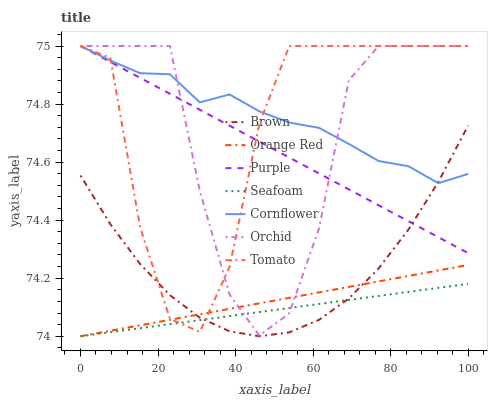Does Seafoam have the minimum area under the curve?
Answer yes or no. Yes. Does Cornflower have the maximum area under the curve?
Answer yes or no. Yes. Does Brown have the minimum area under the curve?
Answer yes or no. No. Does Brown have the maximum area under the curve?
Answer yes or no. No. Is Orange Red the smoothest?
Answer yes or no. Yes. Is Tomato the roughest?
Answer yes or no. Yes. Is Brown the smoothest?
Answer yes or no. No. Is Brown the roughest?
Answer yes or no. No. Does Seafoam have the lowest value?
Answer yes or no. Yes. Does Brown have the lowest value?
Answer yes or no. No. Does Orchid have the highest value?
Answer yes or no. Yes. Does Brown have the highest value?
Answer yes or no. No. Is Seafoam less than Cornflower?
Answer yes or no. Yes. Is Purple greater than Orange Red?
Answer yes or no. Yes. Does Brown intersect Tomato?
Answer yes or no. Yes. Is Brown less than Tomato?
Answer yes or no. No. Is Brown greater than Tomato?
Answer yes or no. No. Does Seafoam intersect Cornflower?
Answer yes or no. No. 